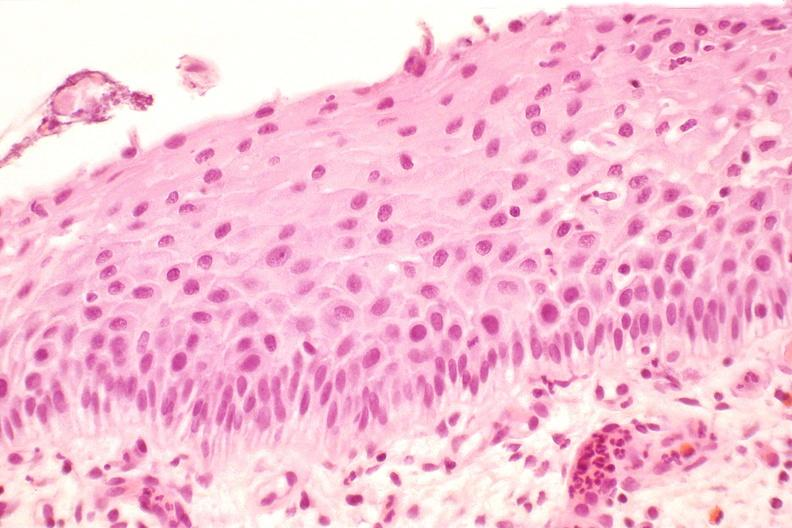s female reproductive present?
Answer the question using a single word or phrase. Yes 